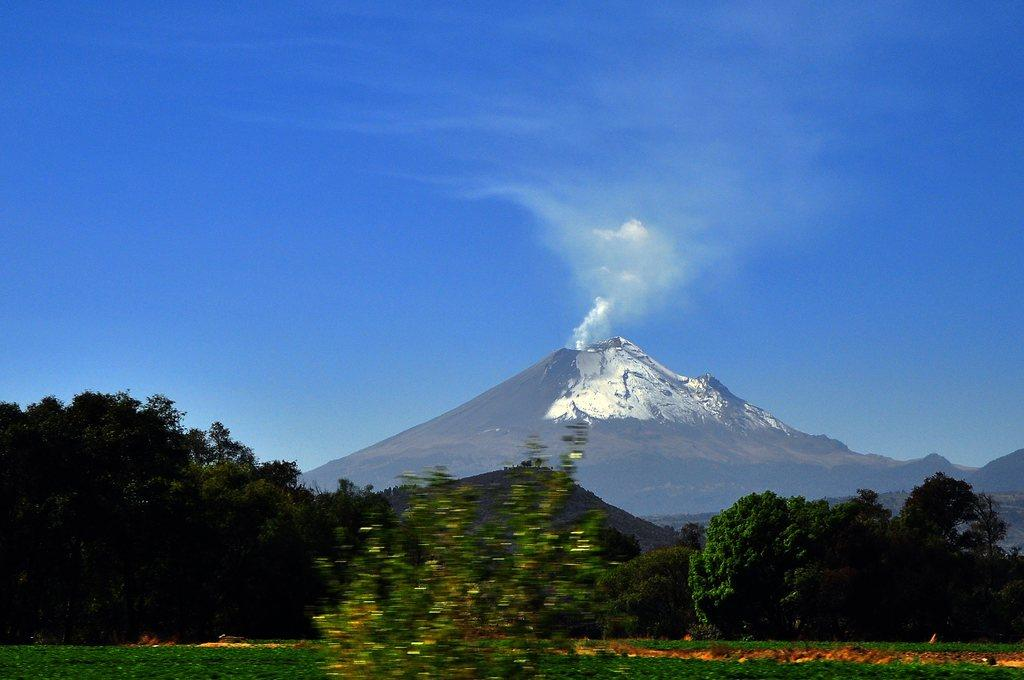What can be seen at the top of the image? The sky is visible towards the top of the image. What type of natural landforms are present in the image? There are mountains in the image. What is the source of the smoke in the image? The source of the smoke is not specified in the image. What type of vegetation is present in the image? There are trees in the image. What type of ground cover is present towards the bottom of the image? There is grass towards the bottom of the image. What type of flag is flying at the airport in the image? There is no airport or flag present in the image. What color is the colorful object in the image? There is no colorful object present in the image. 